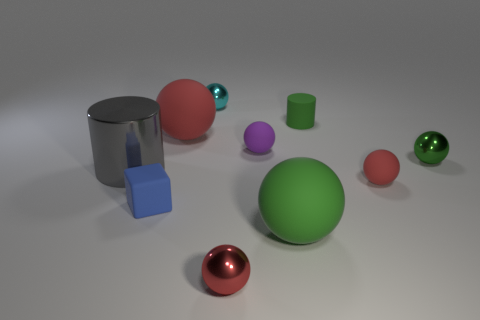Subtract all large red balls. How many balls are left? 6 Subtract all balls. How many objects are left? 3 Subtract all gray cylinders. How many cylinders are left? 1 Subtract 1 cylinders. How many cylinders are left? 1 Subtract all yellow balls. How many purple blocks are left? 0 Subtract all blue rubber cylinders. Subtract all blocks. How many objects are left? 9 Add 2 large green rubber balls. How many large green rubber balls are left? 3 Add 9 tiny cyan objects. How many tiny cyan objects exist? 10 Subtract 0 brown cylinders. How many objects are left? 10 Subtract all green balls. Subtract all purple blocks. How many balls are left? 5 